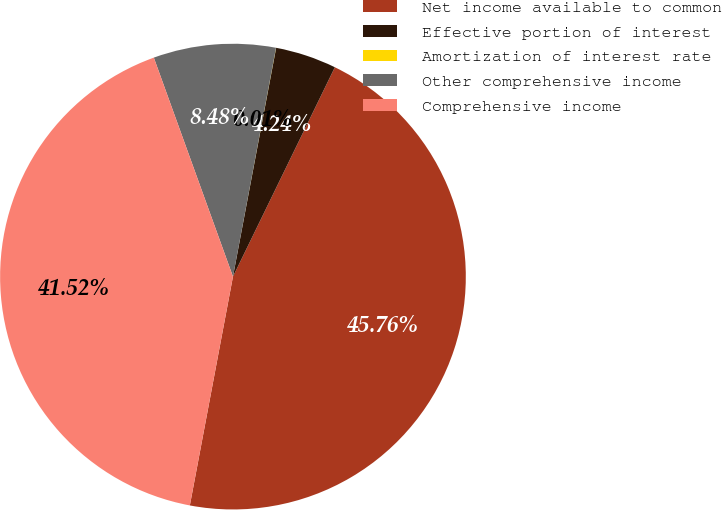<chart> <loc_0><loc_0><loc_500><loc_500><pie_chart><fcel>Net income available to common<fcel>Effective portion of interest<fcel>Amortization of interest rate<fcel>Other comprehensive income<fcel>Comprehensive income<nl><fcel>45.76%<fcel>4.24%<fcel>0.01%<fcel>8.48%<fcel>41.52%<nl></chart> 